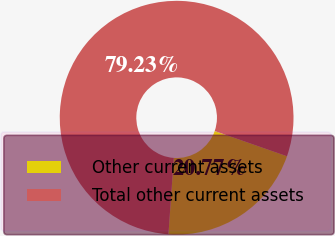<chart> <loc_0><loc_0><loc_500><loc_500><pie_chart><fcel>Other current assets<fcel>Total other current assets<nl><fcel>20.77%<fcel>79.23%<nl></chart> 